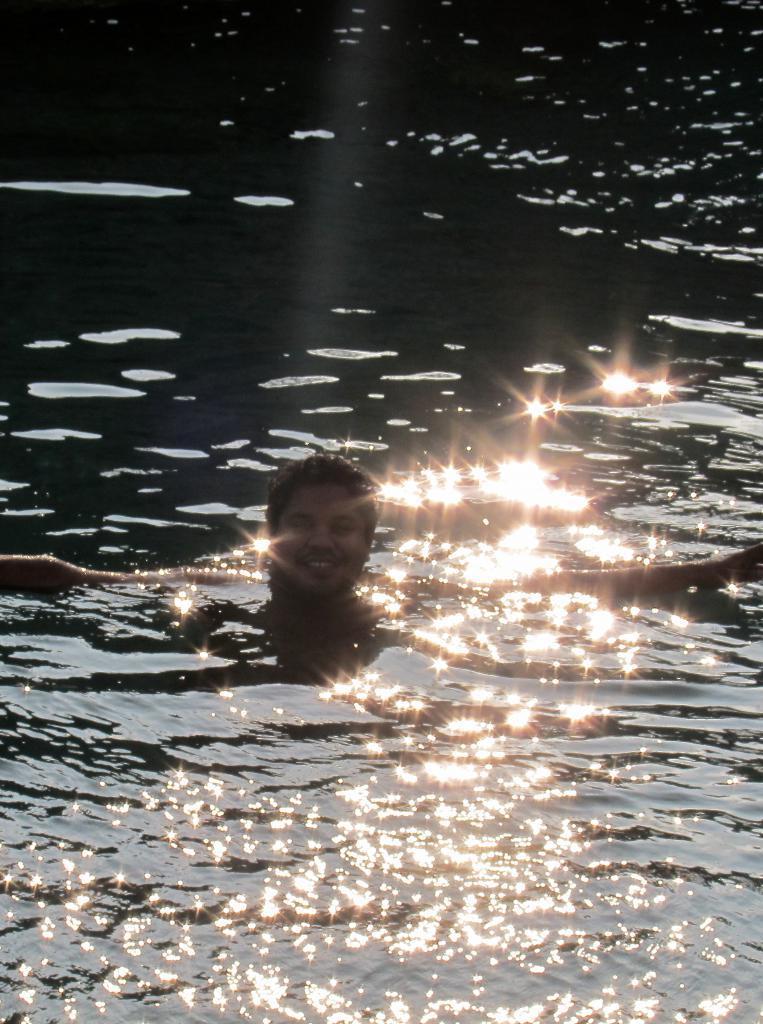Describe this image in one or two sentences. In this image we can see a person in the water and some light reflection is there on the water which is shining. 